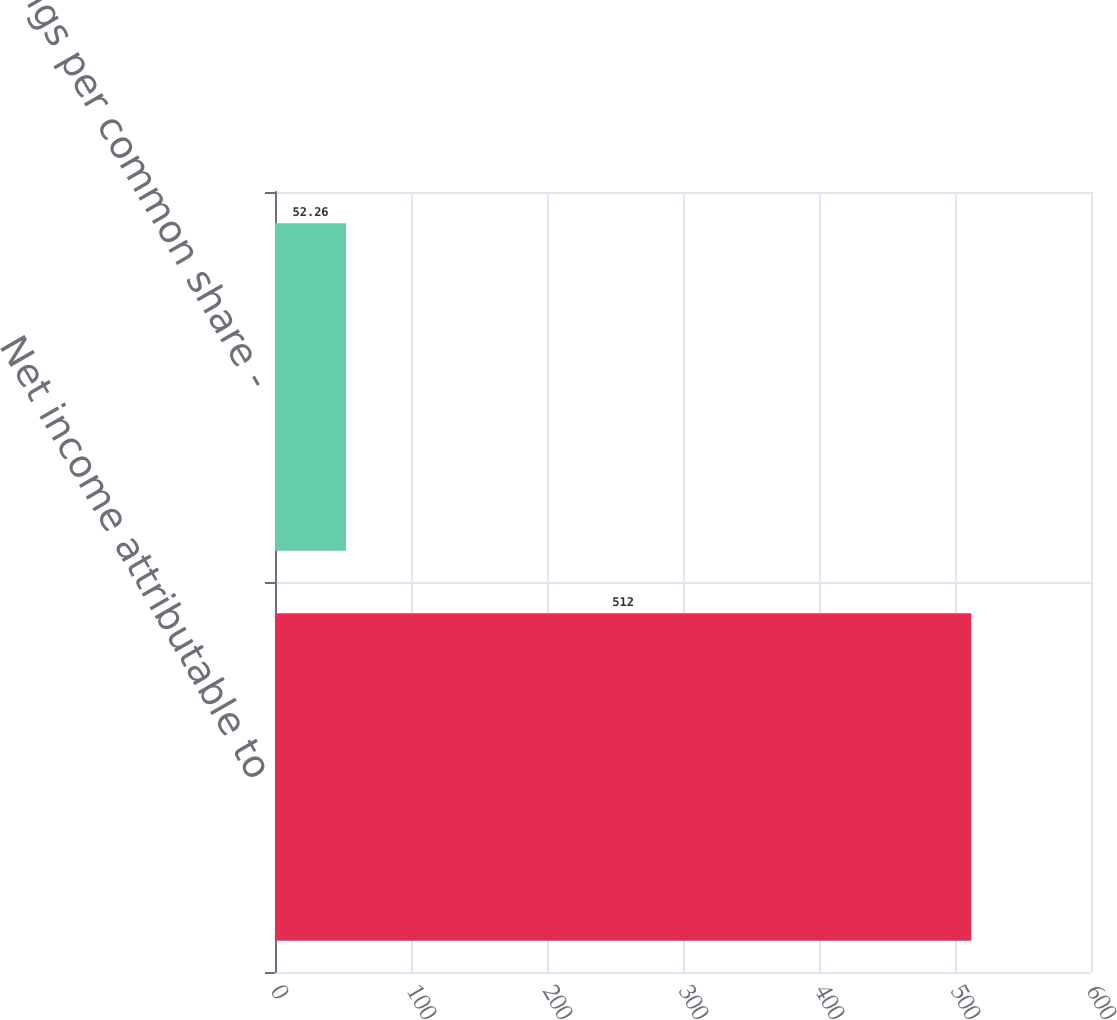Convert chart to OTSL. <chart><loc_0><loc_0><loc_500><loc_500><bar_chart><fcel>Net income attributable to<fcel>Earnings per common share -<nl><fcel>512<fcel>52.26<nl></chart> 